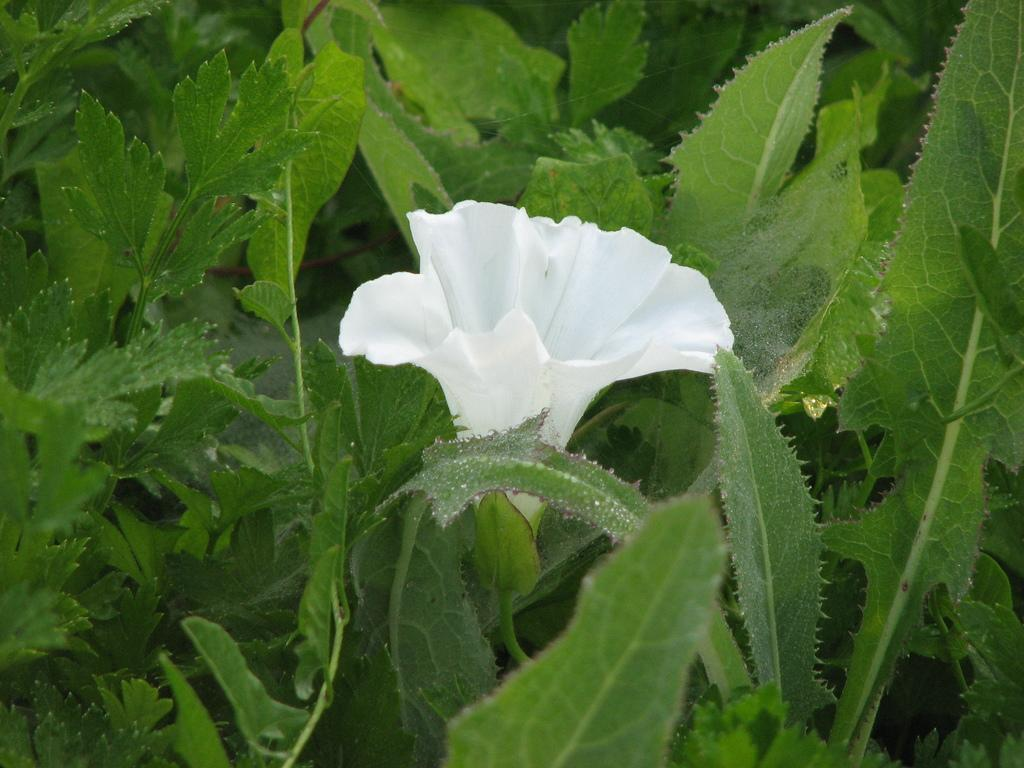What is present in the image? There is a plant in the image. What can be observed about the plant? The plant has a flower. What type of operation is being performed on the plant in the image? There is no operation being performed on the plant in the image; it is simply a plant with a flower. 